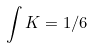Convert formula to latex. <formula><loc_0><loc_0><loc_500><loc_500>\int K = 1 / 6</formula> 